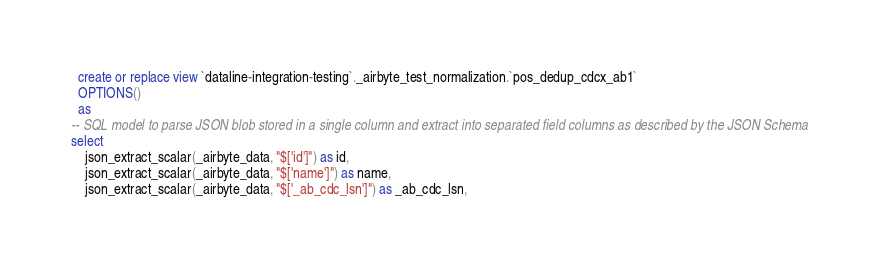Convert code to text. <code><loc_0><loc_0><loc_500><loc_500><_SQL_>

  create or replace view `dataline-integration-testing`._airbyte_test_normalization.`pos_dedup_cdcx_ab1`
  OPTIONS()
  as 
-- SQL model to parse JSON blob stored in a single column and extract into separated field columns as described by the JSON Schema
select
    json_extract_scalar(_airbyte_data, "$['id']") as id,
    json_extract_scalar(_airbyte_data, "$['name']") as name,
    json_extract_scalar(_airbyte_data, "$['_ab_cdc_lsn']") as _ab_cdc_lsn,</code> 